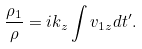Convert formula to latex. <formula><loc_0><loc_0><loc_500><loc_500>\frac { \rho _ { 1 } } { \rho } = i k _ { z } \int v _ { 1 z } d t ^ { \prime } .</formula> 